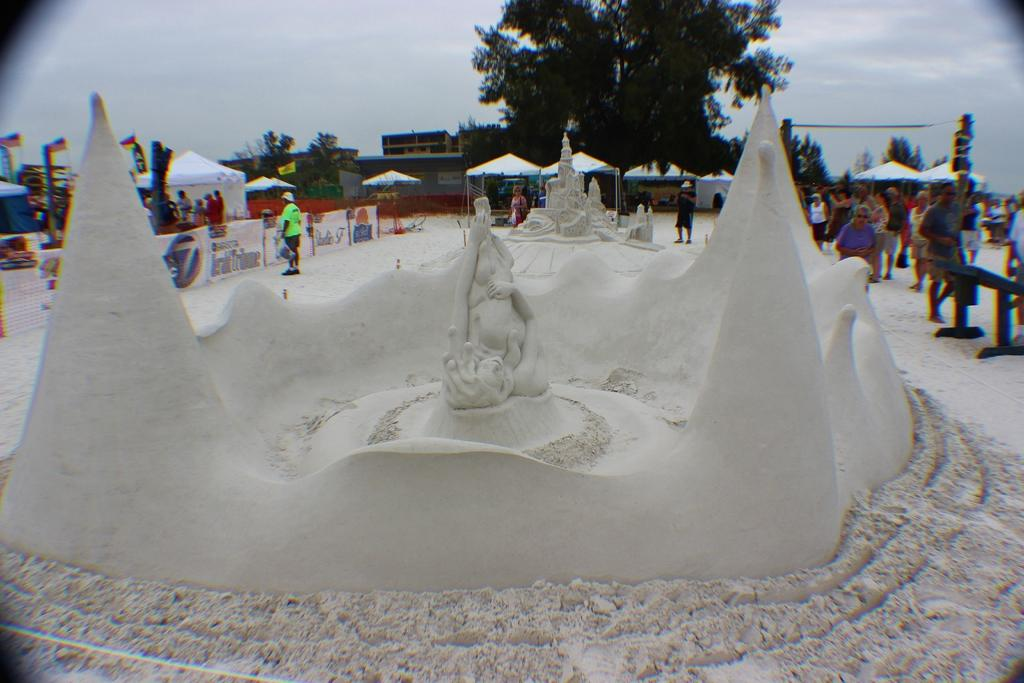What type of art can be seen in the image? There are sand sculptures in the image. What else can be seen in the background of the image? There are groups of people on a path behind the sand sculptures. Are there any commercial establishments visible in the image? Yes, there are stalls visible in the image. What type of natural elements are present in the image? Trees are present in the image. What type of structures can be seen in the image? There are houses in the image. How would you describe the weather in the image? The sky is cloudy in the image. Can you tell me which channel is being broadcasted on the television in the image? There is no television present in the image, so it is not possible to determine which channel is being broadcasted. 